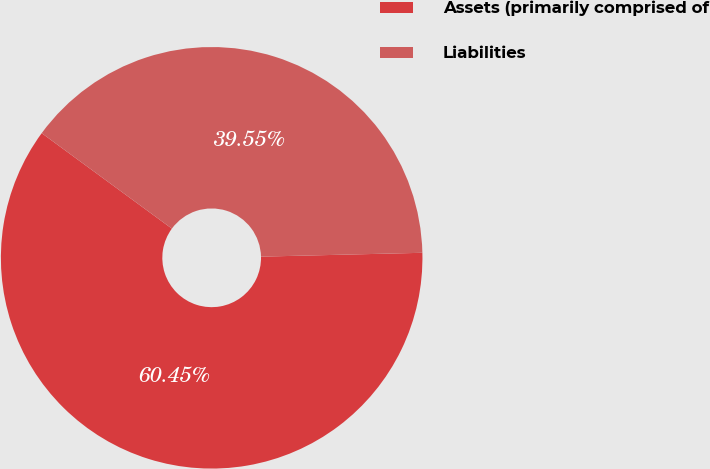Convert chart. <chart><loc_0><loc_0><loc_500><loc_500><pie_chart><fcel>Assets (primarily comprised of<fcel>Liabilities<nl><fcel>60.45%<fcel>39.55%<nl></chart> 